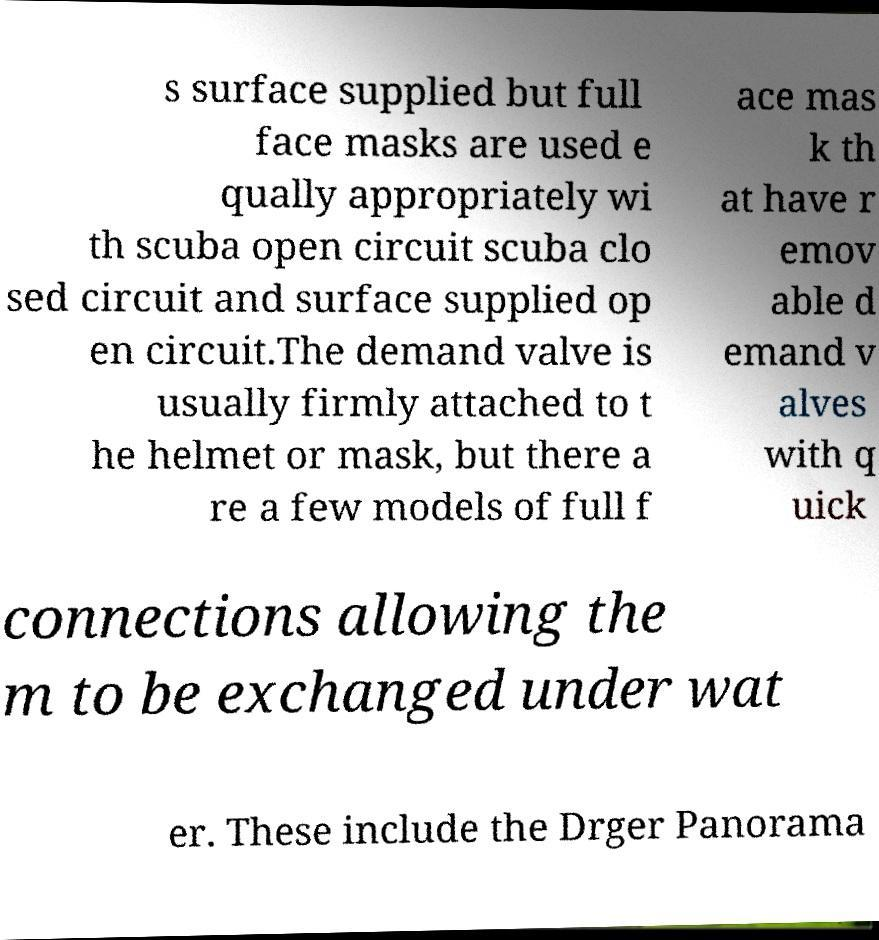What messages or text are displayed in this image? I need them in a readable, typed format. s surface supplied but full face masks are used e qually appropriately wi th scuba open circuit scuba clo sed circuit and surface supplied op en circuit.The demand valve is usually firmly attached to t he helmet or mask, but there a re a few models of full f ace mas k th at have r emov able d emand v alves with q uick connections allowing the m to be exchanged under wat er. These include the Drger Panorama 